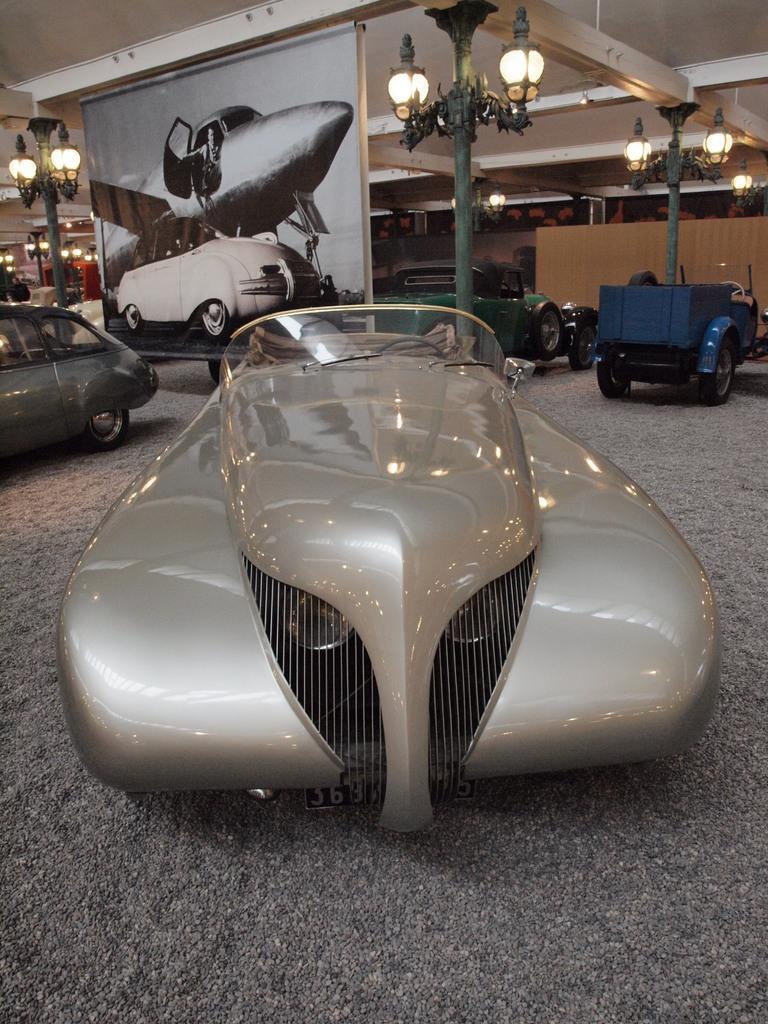Can you describe this image briefly? This picture seems to be clicked inside the hall and we can see the vehicles parked on the ground. In the background we can see the wall, lamp posts, roof, picture of a vehicle on the banner and we can see many other objects. 